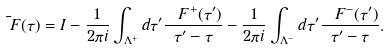<formula> <loc_0><loc_0><loc_500><loc_500>\bar { \ F } ( \tau ) = I - \frac { 1 } { 2 \pi i } \int _ { \Lambda ^ { + } } d \tau ^ { \prime } \frac { \ F ^ { + } ( \tau ^ { \prime } ) } { \tau ^ { \prime } - \tau } - \frac { 1 } { 2 \pi i } \int _ { \Lambda ^ { - } } d \tau ^ { \prime } \frac { \ F ^ { - } ( \tau ^ { \prime } ) } { \tau ^ { \prime } - \tau } .</formula> 